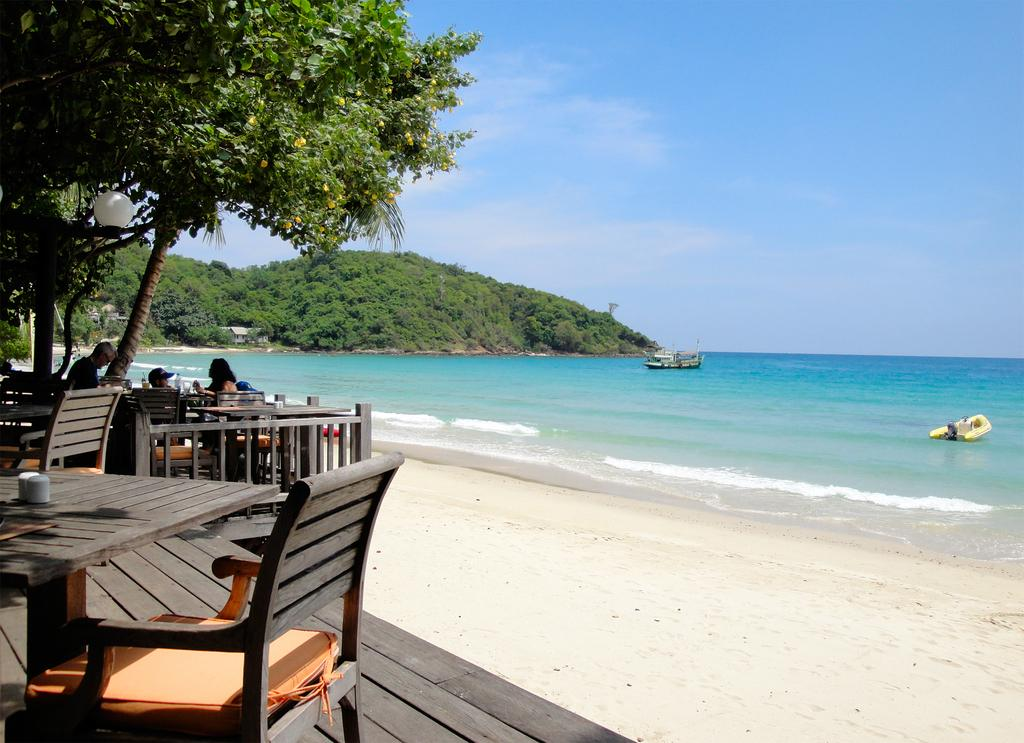What type of furniture is located on the left side of the image? There are chairs and dining tables on the left side of the image. What natural elements can be seen in the image? There are trees in the image. What can be seen on the right side of the image? There are boats sailing in the sea on the right side of the image. Where is the dirt located in the image? There is no dirt present in the image. What type of room is visible in the image? The image does not show a bedroom or any other type of room; it features chairs, dining tables, trees, and boats sailing in the sea. 